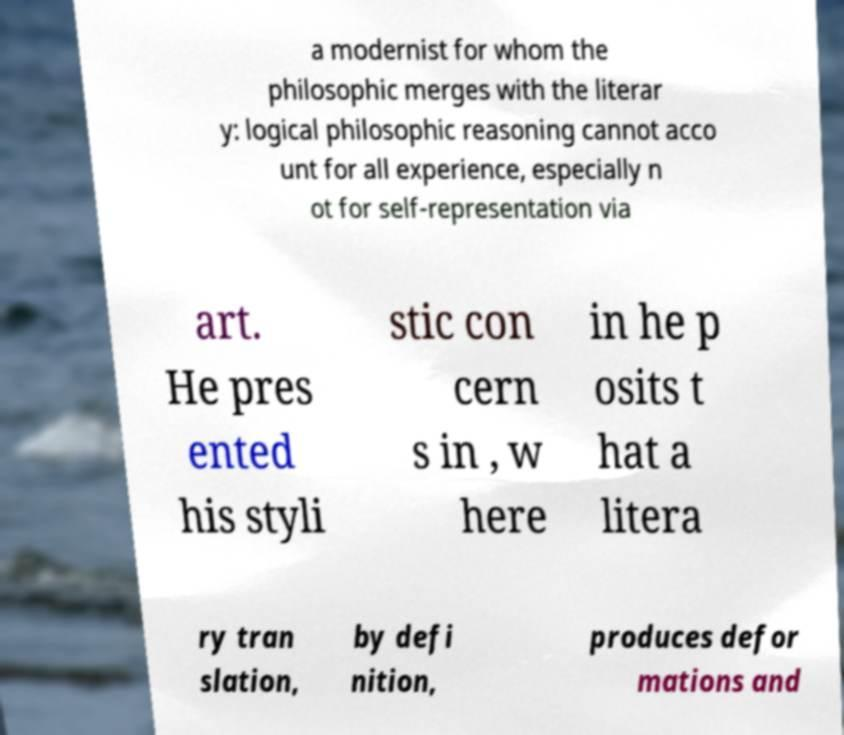There's text embedded in this image that I need extracted. Can you transcribe it verbatim? a modernist for whom the philosophic merges with the literar y: logical philosophic reasoning cannot acco unt for all experience, especially n ot for self-representation via art. He pres ented his styli stic con cern s in , w here in he p osits t hat a litera ry tran slation, by defi nition, produces defor mations and 